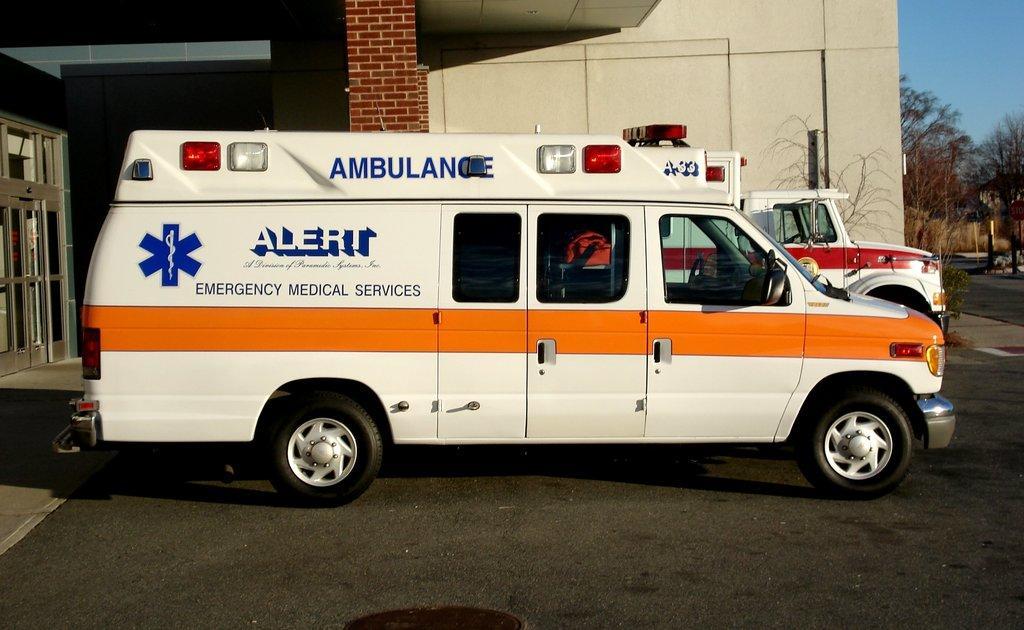Please provide a concise description of this image. In the middle of the picture, we see an ambulance, which is parked on the road. Behind that, we see a vehicle in white color is parked on the road. In the background, we see a wall which is made up of bricks. Beside that, we see a building in white color. On the right side, there are trees. At the bottom of the picture, we see the road. In the right top of the picture, we see the sky. 